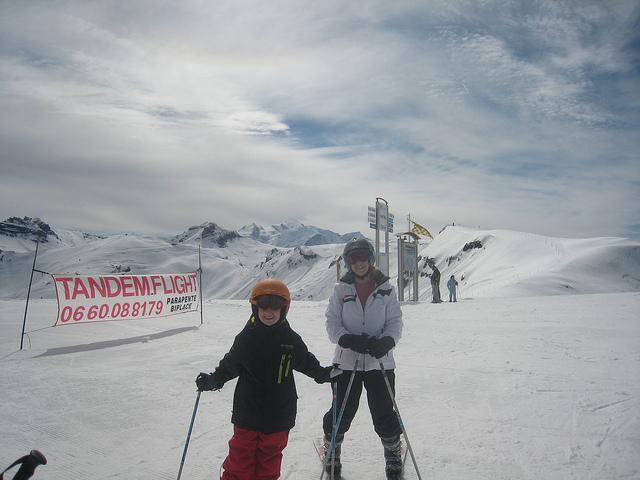What type of activity is this? skiing 